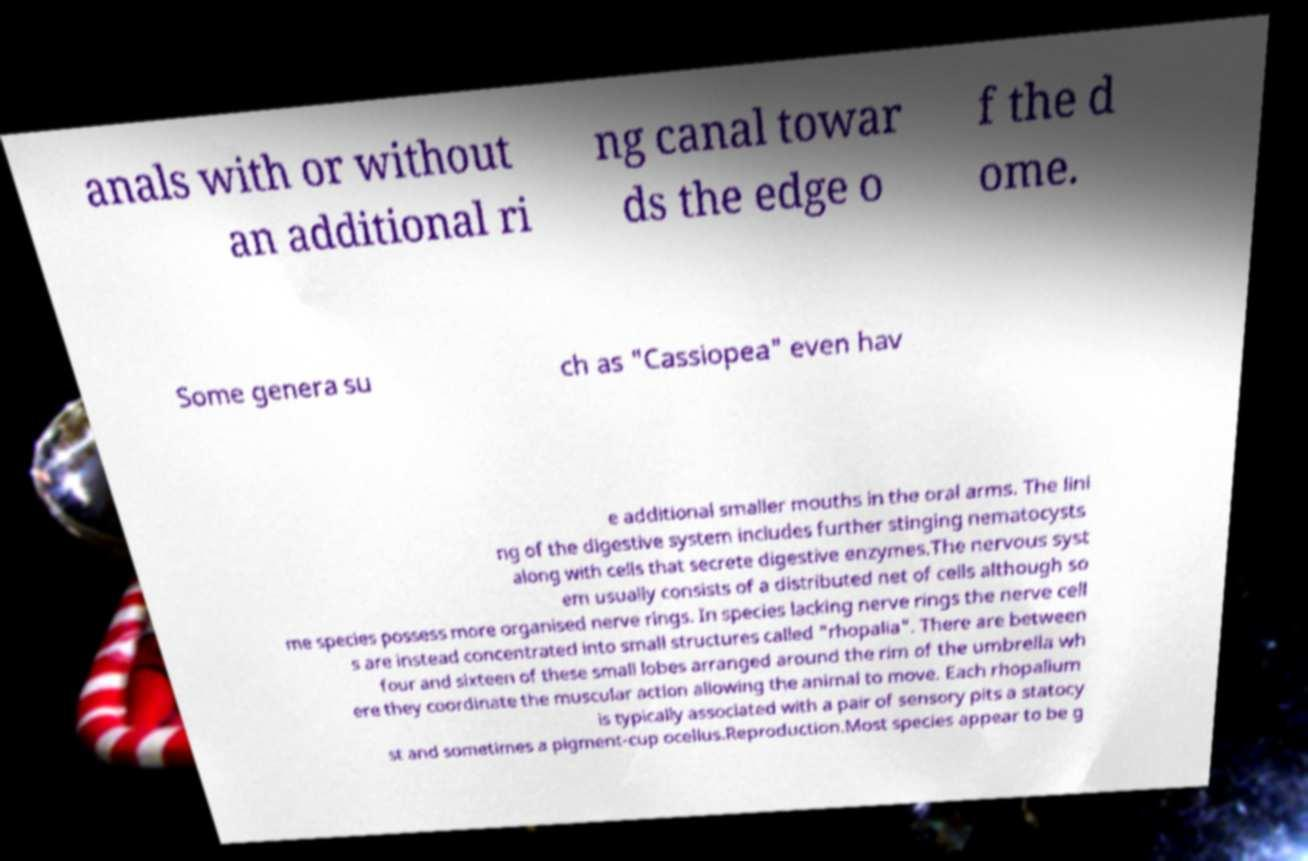Can you accurately transcribe the text from the provided image for me? anals with or without an additional ri ng canal towar ds the edge o f the d ome. Some genera su ch as "Cassiopea" even hav e additional smaller mouths in the oral arms. The lini ng of the digestive system includes further stinging nematocysts along with cells that secrete digestive enzymes.The nervous syst em usually consists of a distributed net of cells although so me species possess more organised nerve rings. In species lacking nerve rings the nerve cell s are instead concentrated into small structures called "rhopalia". There are between four and sixteen of these small lobes arranged around the rim of the umbrella wh ere they coordinate the muscular action allowing the animal to move. Each rhopalium is typically associated with a pair of sensory pits a statocy st and sometimes a pigment-cup ocellus.Reproduction.Most species appear to be g 